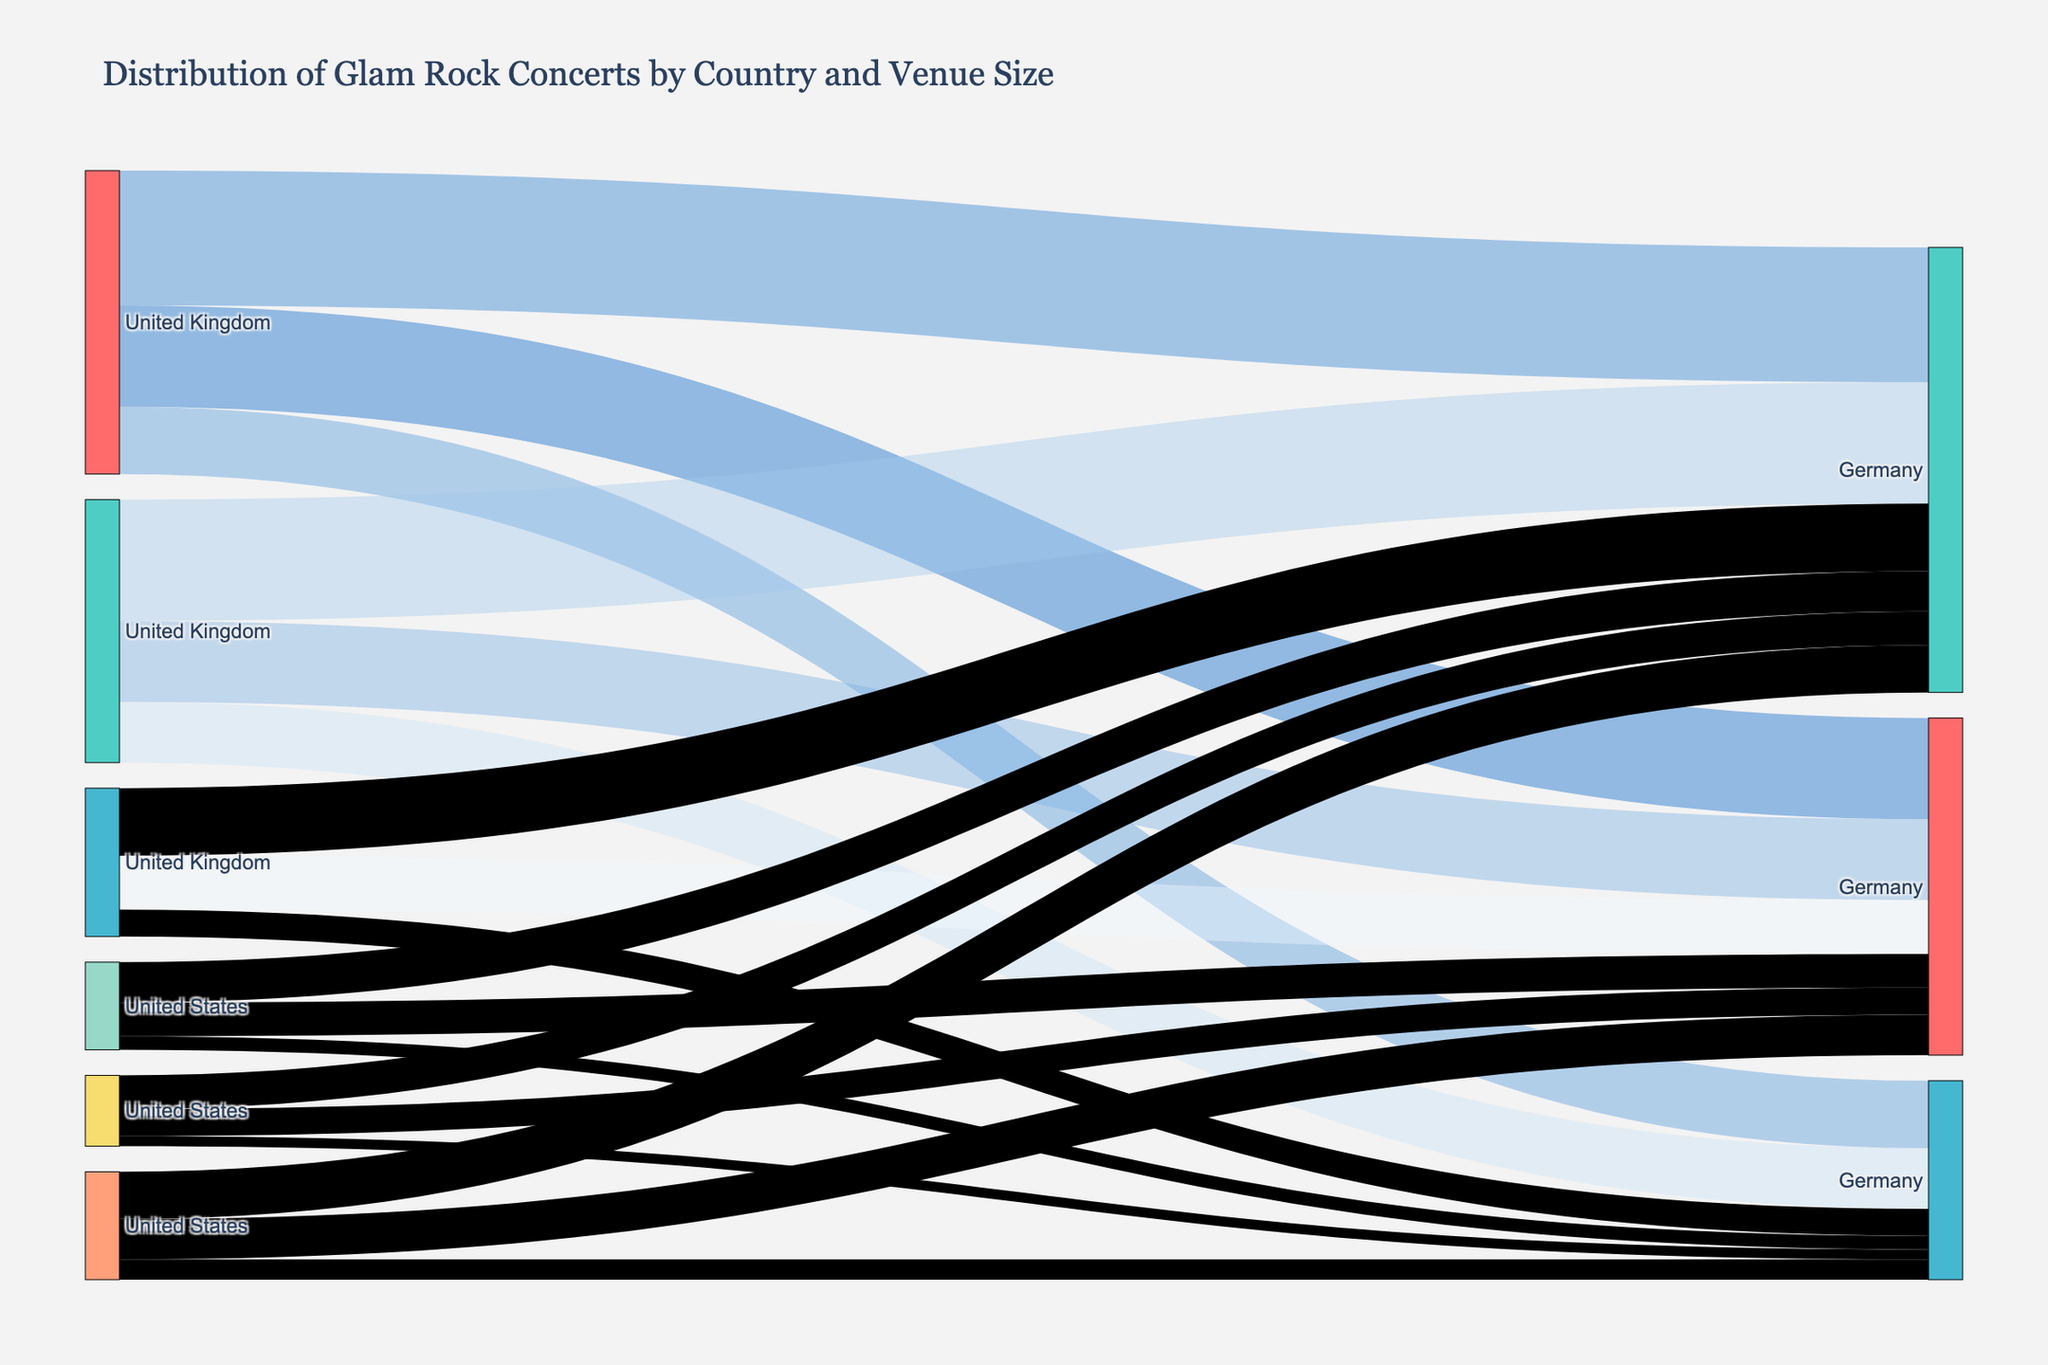What's the title of the figure? The title is usually at the top of the figure and provides a brief description of what the figure represents. In this case, the title is "Distribution of Glam Rock Concerts by Country and Venue Size."
Answer: Distribution of Glam Rock Concerts by Country and Venue Size How many concerts were held in the United States in total? First, identify the number of concerts in each venue size for the United States: Small (120), Medium (180), and Large (90). Then, sum them: 120 + 180 + 90 = 390.
Answer: 390 Which country has the highest number of medium-sized venue concerts and how many? Look at the Medium-sized venue segment for each country. The United Kingdom has 200 concerts, which is the highest compared to other countries.
Answer: United Kingdom, 200 What is the total number of glam rock concerts held in large venues across all countries? Sum the number of concerts in large venues for each country: UK (100), US (90), Germany (40), Japan (30), Australia (20), France (15). 100 + 90 + 40 + 30 + 20 + 15 = 295.
Answer: 295 Which country had the smallest number of glam rock concerts in small venues, and what is that number? Compare the number of concerts in small venues for each country: France (40), Australia (50), Japan (60), Germany (80), United States (120), United Kingdom (150). France has the smallest number with 40 concerts.
Answer: France, 40 Are there more concerts in medium-sized venues or large venues in Germany? By how many? Identify the number of concerts in Medium (100) and Large (40) venues in Germany. To find the difference: 100 - 40 = 60. There are 60 more concerts in Medium-sized venues.
Answer: Medium, 60 more In which country is the distribution of concerts across venue sizes most balanced? Look for the most even distribution by comparing numbers across venue sizes within each country. For instance, Germany has 80 (small), 100 (medium), and 40 (large). Other countries have more pronounced differences.
Answer: Germany What is the ratio of small to large venue concerts in Japan? Identify the number of concerts in Small (60) and Large (30) venues in Japan. The ratio is 60:30, which simplifies to 2:1.
Answer: 2:1 Which has more concerts: Small and Medium venues in the United States combined, or Large venues in the United Kingdom? Sum the concerts in Small (120) and Medium (180) venues in the US: 120 + 180 = 300. Compare it to Large (100) venues in the UK. 300 is more than 100.
Answer: Small and Medium in the US How does the number of concerts in Australia compare to those in France across all venue sizes? First, tally the total number of concerts for each country. Australia: 50 (small) + 60 (medium) + 20 (large) = 130. France: 40 (small) + 50 (medium) + 15 (large) = 105. Australia has more concerts.
Answer: Australia, more 